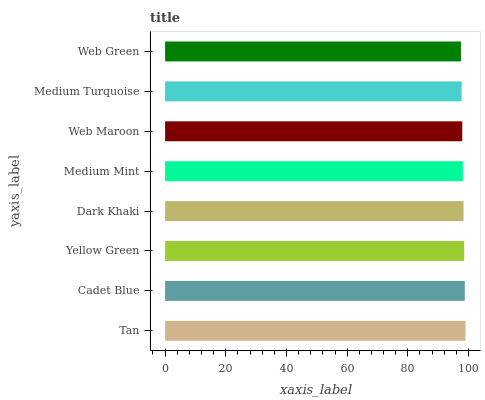Is Web Green the minimum?
Answer yes or no. Yes. Is Tan the maximum?
Answer yes or no. Yes. Is Cadet Blue the minimum?
Answer yes or no. No. Is Cadet Blue the maximum?
Answer yes or no. No. Is Tan greater than Cadet Blue?
Answer yes or no. Yes. Is Cadet Blue less than Tan?
Answer yes or no. Yes. Is Cadet Blue greater than Tan?
Answer yes or no. No. Is Tan less than Cadet Blue?
Answer yes or no. No. Is Dark Khaki the high median?
Answer yes or no. Yes. Is Medium Mint the low median?
Answer yes or no. Yes. Is Yellow Green the high median?
Answer yes or no. No. Is Medium Turquoise the low median?
Answer yes or no. No. 